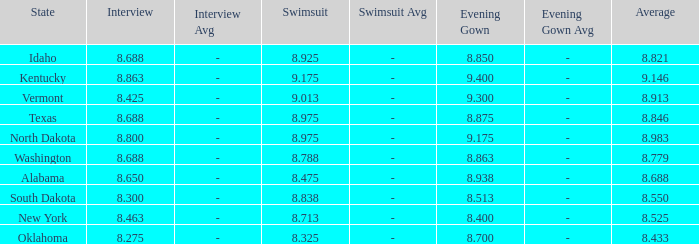Could you parse the entire table? {'header': ['State', 'Interview', 'Interview Avg', 'Swimsuit', 'Swimsuit Avg', 'Evening Gown', 'Evening Gown Avg', 'Average'], 'rows': [['Idaho', '8.688', '-', '8.925', '-', '8.850', '-', '8.821'], ['Kentucky', '8.863', '-', '9.175', '-', '9.400', '-', '9.146'], ['Vermont', '8.425', '-', '9.013', '-', '9.300', '-', '8.913'], ['Texas', '8.688', '-', '8.975', '-', '8.875', '-', '8.846'], ['North Dakota', '8.800', '-', '8.975', '-', '9.175', '-', '8.983'], ['Washington', '8.688', '-', '8.788', '-', '8.863', '-', '8.779'], ['Alabama', '8.650', '-', '8.475', '-', '8.938', '-', '8.688'], ['South Dakota', '8.300', '-', '8.838', '-', '8.513', '-', '8.550'], ['New York', '8.463', '-', '8.713', '-', '8.400', '-', '8.525'], ['Oklahoma', '8.275', '-', '8.325', '-', '8.700', '-', '8.433']]} What is the lowest average of the contestant with an interview of 8.275 and an evening gown bigger than 8.7? None. 